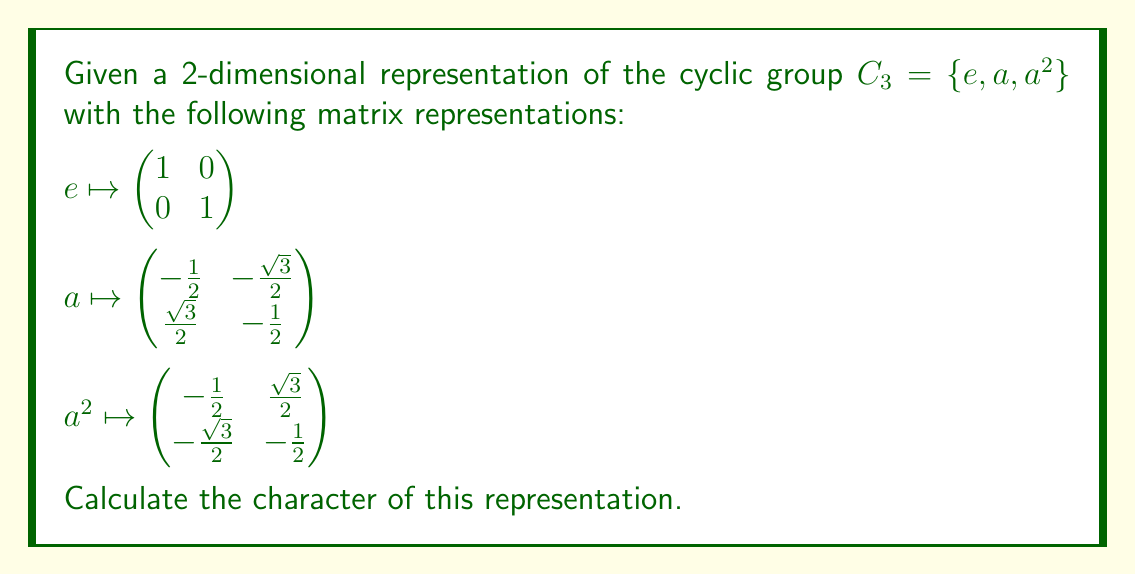Help me with this question. To determine the character of a group representation, we need to calculate the trace of each matrix in the representation. The trace of a matrix is the sum of its diagonal elements. Let's go through this step-by-step:

1. For the identity element $e$:
   $$\text{Tr}(e) = \text{Tr}\begin{pmatrix} 1 & 0 \\ 0 & 1 \end{pmatrix} = 1 + 1 = 2$$

2. For the element $a$:
   $$\text{Tr}(a) = \text{Tr}\begin{pmatrix} -\frac{1}{2} & -\frac{\sqrt{3}}{2} \\ \frac{\sqrt{3}}{2} & -\frac{1}{2} \end{pmatrix} = -\frac{1}{2} + (-\frac{1}{2}) = -1$$

3. For the element $a^2$:
   $$\text{Tr}(a^2) = \text{Tr}\begin{pmatrix} -\frac{1}{2} & \frac{\sqrt{3}}{2} \\ -\frac{\sqrt{3}}{2} & -\frac{1}{2} \end{pmatrix} = -\frac{1}{2} + (-\frac{1}{2}) = -1$$

The character of a representation is a function that assigns to each group element the trace of its corresponding matrix. Therefore, the character $\chi$ of this representation is:

$$\chi(e) = 2$$
$$\chi(a) = -1$$
$$\chi(a^2) = -1$$

We can express this as a vector or a list of values: $(2, -1, -1)$.
Answer: $(2, -1, -1)$ 